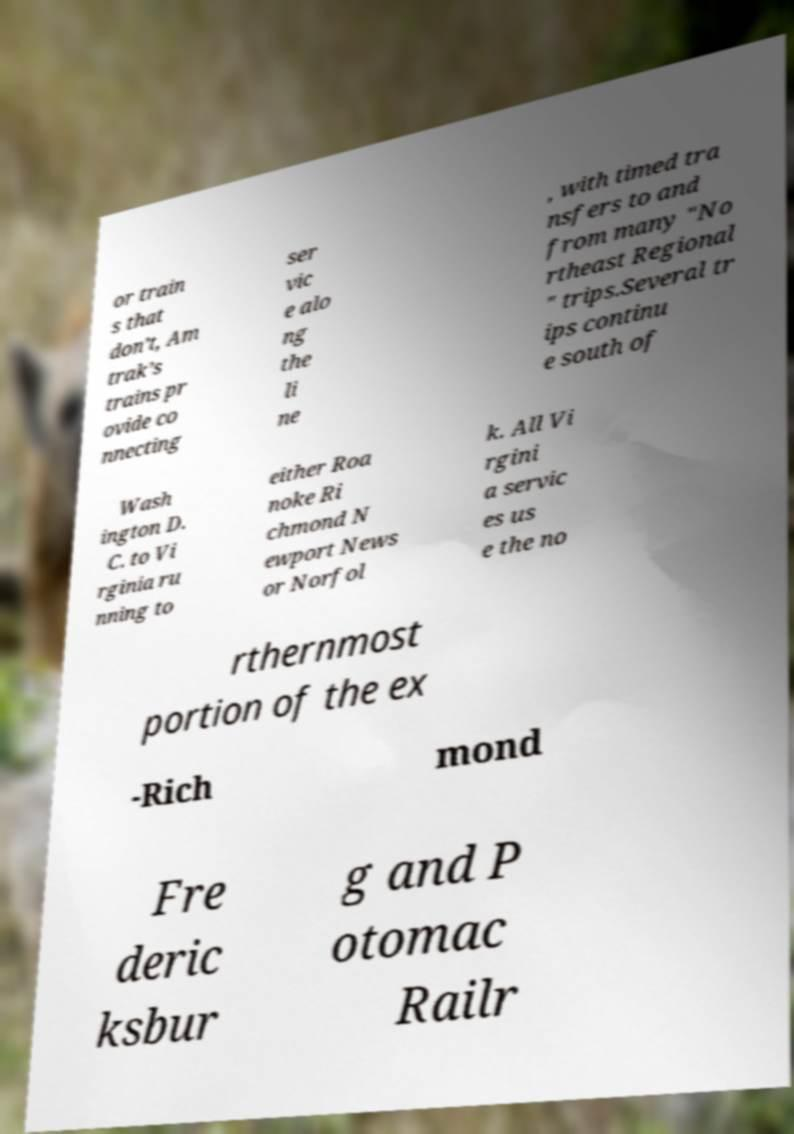Can you accurately transcribe the text from the provided image for me? or train s that don’t, Am trak’s trains pr ovide co nnecting ser vic e alo ng the li ne , with timed tra nsfers to and from many "No rtheast Regional " trips.Several tr ips continu e south of Wash ington D. C. to Vi rginia ru nning to either Roa noke Ri chmond N ewport News or Norfol k. All Vi rgini a servic es us e the no rthernmost portion of the ex -Rich mond Fre deric ksbur g and P otomac Railr 